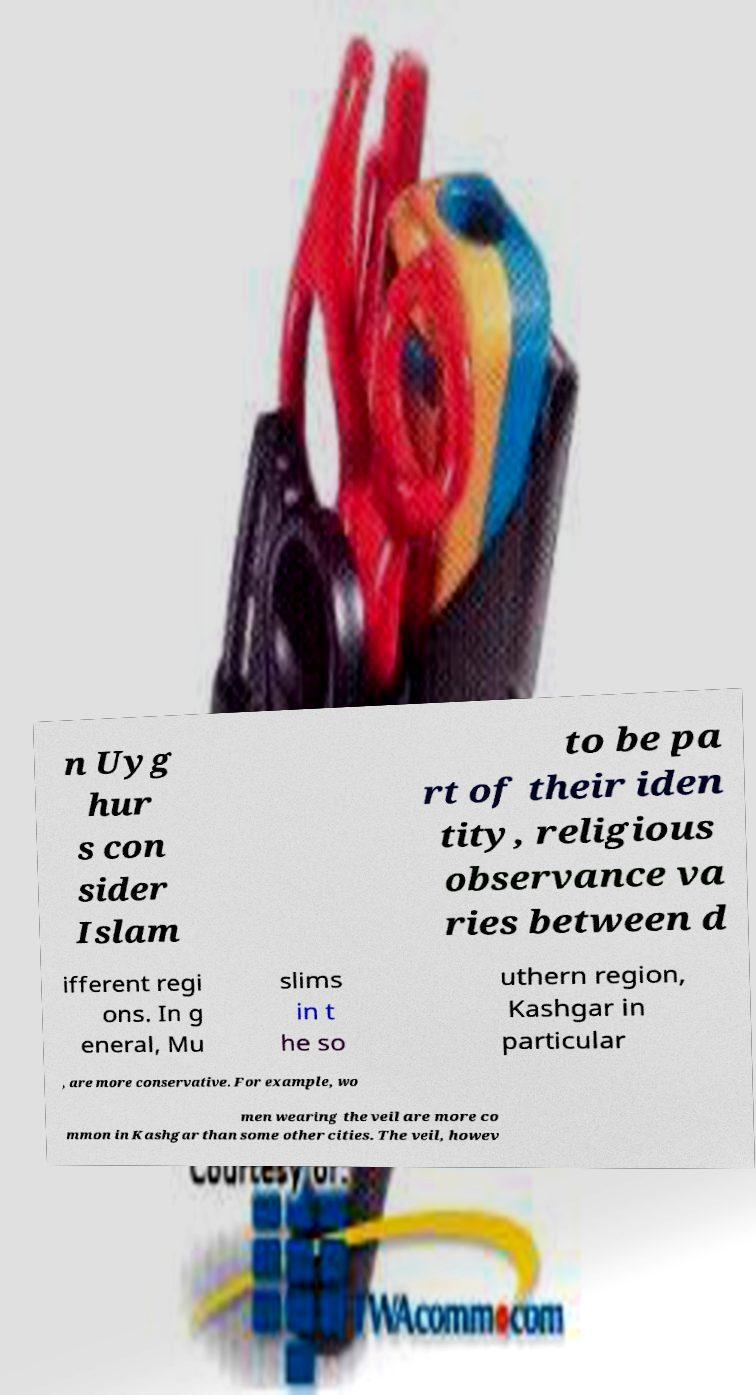Please identify and transcribe the text found in this image. n Uyg hur s con sider Islam to be pa rt of their iden tity, religious observance va ries between d ifferent regi ons. In g eneral, Mu slims in t he so uthern region, Kashgar in particular , are more conservative. For example, wo men wearing the veil are more co mmon in Kashgar than some other cities. The veil, howev 